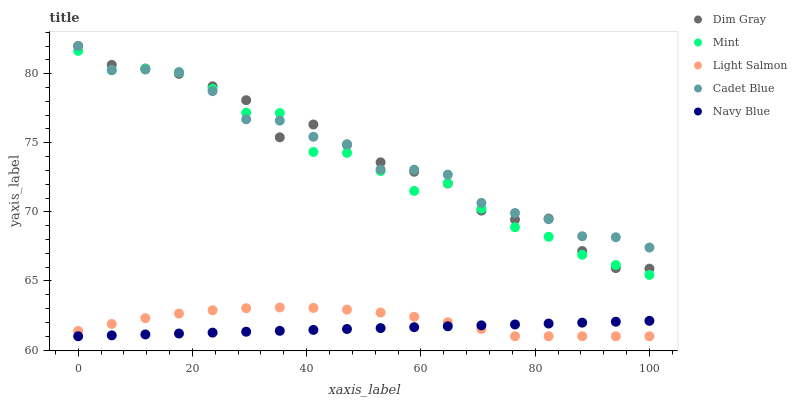Does Navy Blue have the minimum area under the curve?
Answer yes or no. Yes. Does Cadet Blue have the maximum area under the curve?
Answer yes or no. Yes. Does Light Salmon have the minimum area under the curve?
Answer yes or no. No. Does Light Salmon have the maximum area under the curve?
Answer yes or no. No. Is Navy Blue the smoothest?
Answer yes or no. Yes. Is Mint the roughest?
Answer yes or no. Yes. Is Light Salmon the smoothest?
Answer yes or no. No. Is Light Salmon the roughest?
Answer yes or no. No. Does Navy Blue have the lowest value?
Answer yes or no. Yes. Does Dim Gray have the lowest value?
Answer yes or no. No. Does Dim Gray have the highest value?
Answer yes or no. Yes. Does Light Salmon have the highest value?
Answer yes or no. No. Is Navy Blue less than Dim Gray?
Answer yes or no. Yes. Is Dim Gray greater than Navy Blue?
Answer yes or no. Yes. Does Cadet Blue intersect Mint?
Answer yes or no. Yes. Is Cadet Blue less than Mint?
Answer yes or no. No. Is Cadet Blue greater than Mint?
Answer yes or no. No. Does Navy Blue intersect Dim Gray?
Answer yes or no. No. 